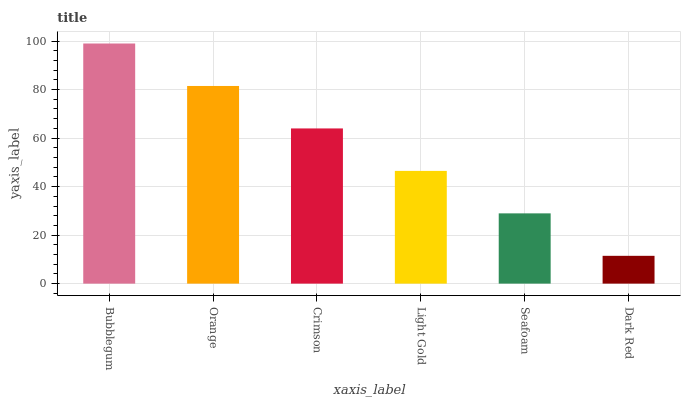Is Dark Red the minimum?
Answer yes or no. Yes. Is Bubblegum the maximum?
Answer yes or no. Yes. Is Orange the minimum?
Answer yes or no. No. Is Orange the maximum?
Answer yes or no. No. Is Bubblegum greater than Orange?
Answer yes or no. Yes. Is Orange less than Bubblegum?
Answer yes or no. Yes. Is Orange greater than Bubblegum?
Answer yes or no. No. Is Bubblegum less than Orange?
Answer yes or no. No. Is Crimson the high median?
Answer yes or no. Yes. Is Light Gold the low median?
Answer yes or no. Yes. Is Dark Red the high median?
Answer yes or no. No. Is Seafoam the low median?
Answer yes or no. No. 